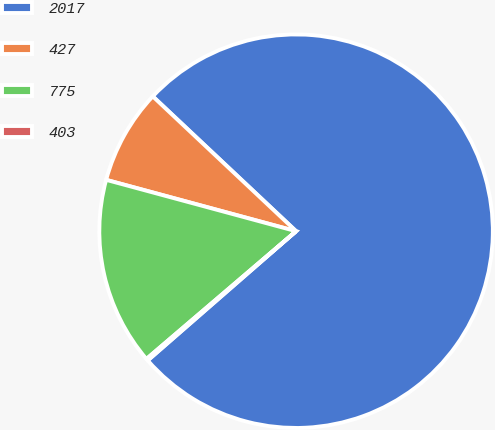Convert chart. <chart><loc_0><loc_0><loc_500><loc_500><pie_chart><fcel>2017<fcel>427<fcel>775<fcel>403<nl><fcel>76.58%<fcel>7.81%<fcel>15.45%<fcel>0.16%<nl></chart> 